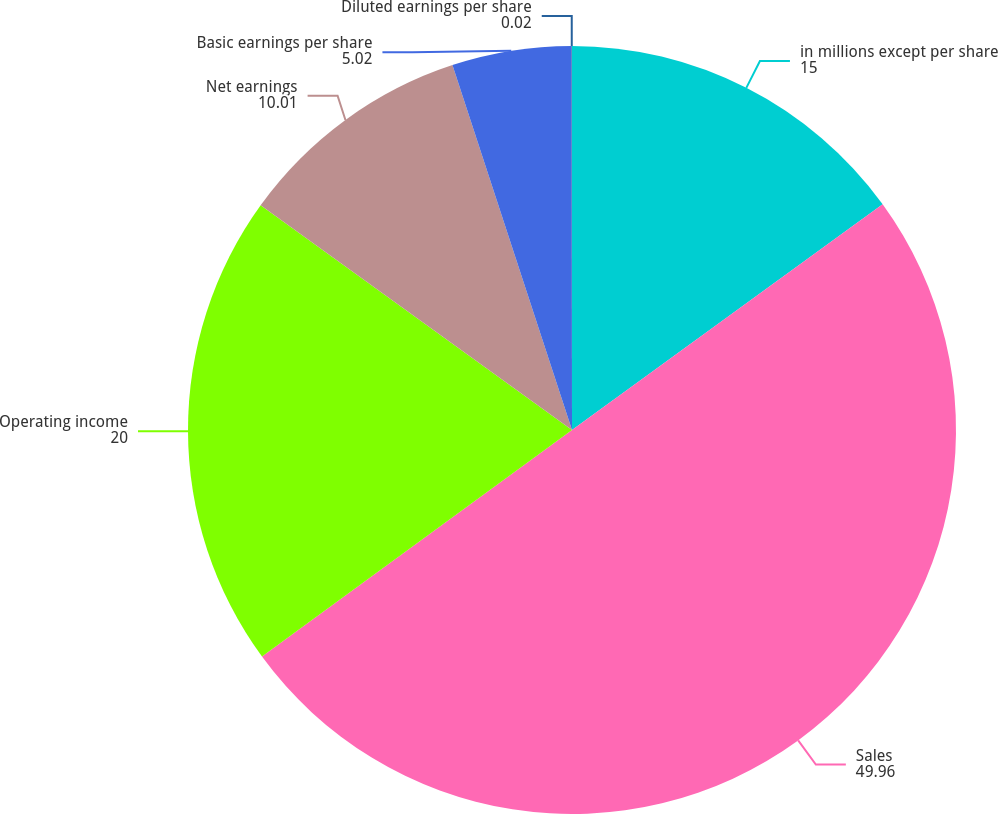<chart> <loc_0><loc_0><loc_500><loc_500><pie_chart><fcel>in millions except per share<fcel>Sales<fcel>Operating income<fcel>Net earnings<fcel>Basic earnings per share<fcel>Diluted earnings per share<nl><fcel>15.0%<fcel>49.96%<fcel>20.0%<fcel>10.01%<fcel>5.02%<fcel>0.02%<nl></chart> 